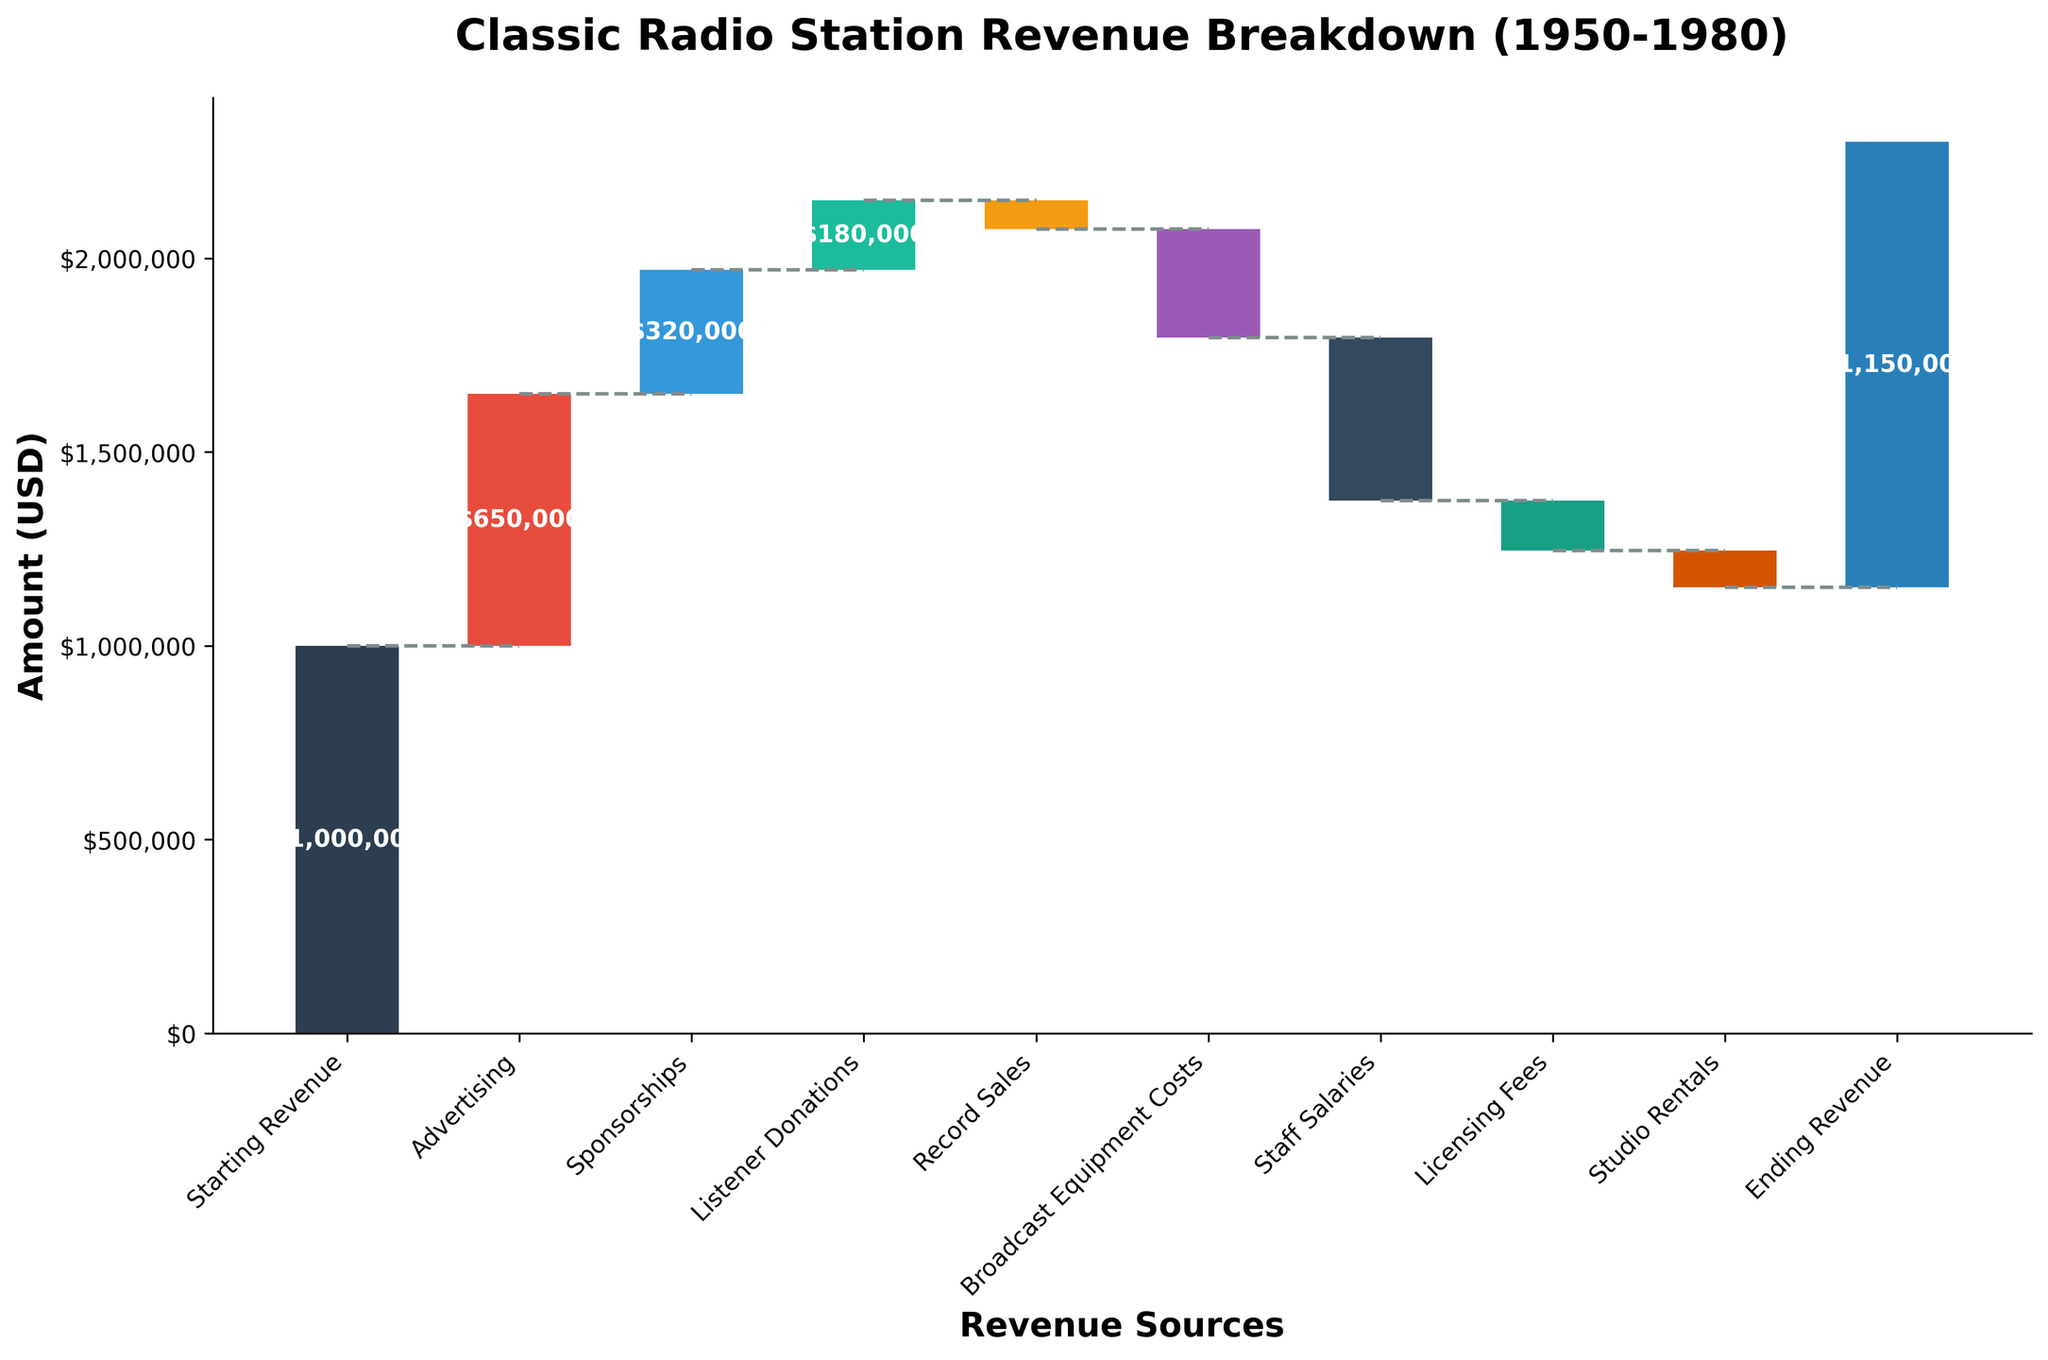What is the title of the chart? The title of the chart can be found at the top of the figure in bold, it reads "Classic Radio Station Revenue Breakdown (1950-1980)".
Answer: Classic Radio Station Revenue Breakdown (1950-1980) What is the starting revenue? The starting revenue is indicated by the first bar on the left side of the chart, which is labeled "Starting Revenue".
Answer: $1,000,000 What is the ending revenue? The ending revenue is indicated by the last bar on the right side of the chart, which is labeled "Ending Revenue".
Answer: $1,150,000 Which category has the highest positive contribution to the revenue? By looking at the bars extending upwards from the baseline, the "Advertising" category has the highest positive value.
Answer: Advertising What is the total contribution of negative revenue sources? To find the total, sum up all the negative contributions: -$75,000 (Record Sales) - $280,000 (Broadcast Equipment Costs) - $420,000 (Staff Salaries) - $130,000 (Licensing Fees) - $95,000 (Studio Rentals).
Answer: -$1,000,000 Which category has the least negative impact on revenue? Among the downward bars, the one with the least absolute value is "Record Sales".
Answer: Record Sales What is the net increase in revenue from starting to ending revenue? The net increase is calculated by subtracting the starting revenue from the ending revenue: $1,150,000 - $1,000,000.
Answer: $150,000 Which two categories combined have an impact closest to $600,000? By adding up positive and negative values, "Advertising" ($650,000) and "Record Sales" (-$75,000) have a combined impact: $650,000 - $75,000.
Answer: Advertising and Record Sales How does the contribution of 'Listener Donations' compare to 'Sponsorships'? Compare the values directly: "Listener Donations" ($180,000) is less than "Sponsorships" ($320,000).
Answer: Listener Donations is less than Sponsorships What is the cumulative revenue after considering 'Broadcast Equipment Costs'? Cumulative revenue can be obtained by summing from the starting revenue to 'Broadcast Equipment Costs': $1,000,000 + $650,000 + $320,000 + $180,000 - $75,000 - $280,000.
Answer: $1,795,000 